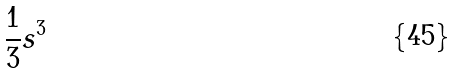<formula> <loc_0><loc_0><loc_500><loc_500>\frac { 1 } { 3 } s ^ { 3 }</formula> 